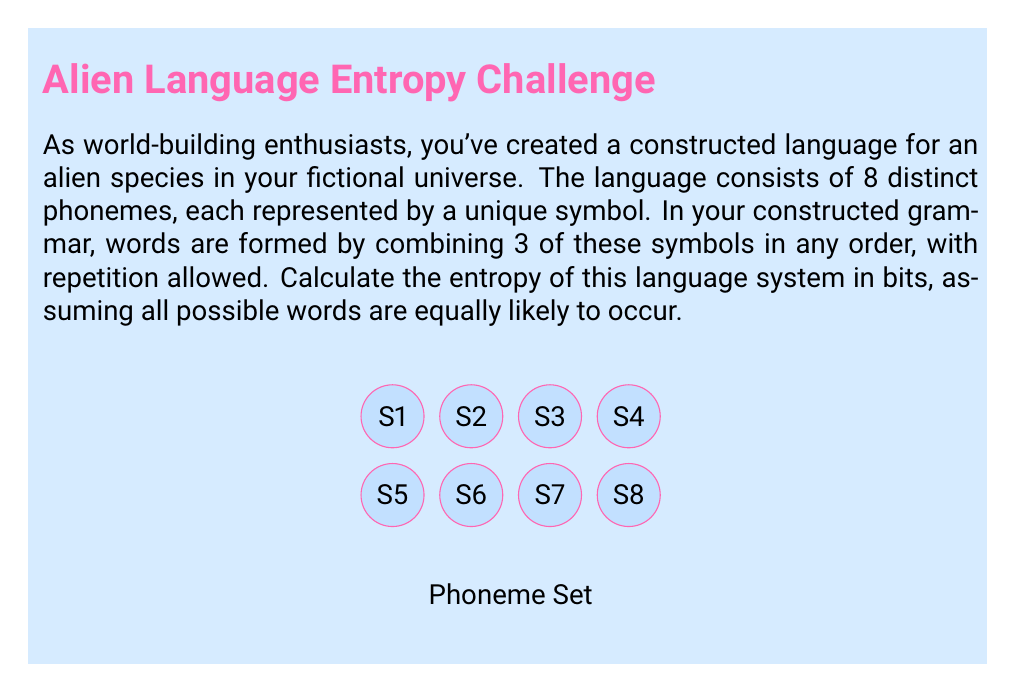Show me your answer to this math problem. To calculate the entropy of this constructed language system, we'll follow these steps:

1) First, let's determine the number of possible words in the language:
   - We have 8 symbols to choose from for each position in a 3-symbol word.
   - This is a case of sampling with replacement, so we use the multiplication principle.
   - Number of possible words = $8 * 8 * 8 = 8^3 = 512$

2) Given that all words are equally likely, the probability of each word occurring is:
   $p = \frac{1}{512}$

3) The entropy formula for a system with equally likely outcomes is:
   $H = \log_2(N)$, where N is the number of possible outcomes.

4) In this case:
   $H = \log_2(512)$

5) We can simplify this:
   $\log_2(512) = \log_2(2^9) = 9$

Therefore, the entropy of this language system is 9 bits.

This means that, on average, 9 bits of information are needed to represent each word in this constructed language system.
Answer: 9 bits 